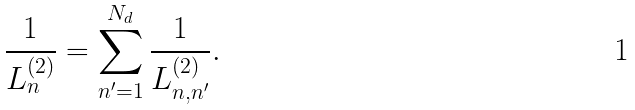<formula> <loc_0><loc_0><loc_500><loc_500>\frac { 1 } { L ^ { ( 2 ) } _ { n } } = \sum _ { n ^ { \prime } = 1 } ^ { N _ { d } } \frac { 1 } { L ^ { ( 2 ) } _ { n , n ^ { \prime } } } .</formula> 